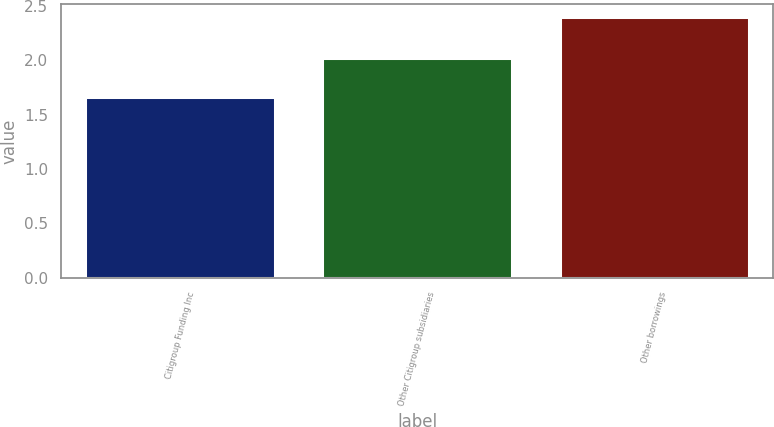Convert chart. <chart><loc_0><loc_0><loc_500><loc_500><bar_chart><fcel>Citigroup Funding Inc<fcel>Other Citigroup subsidiaries<fcel>Other borrowings<nl><fcel>1.66<fcel>2.02<fcel>2.4<nl></chart> 